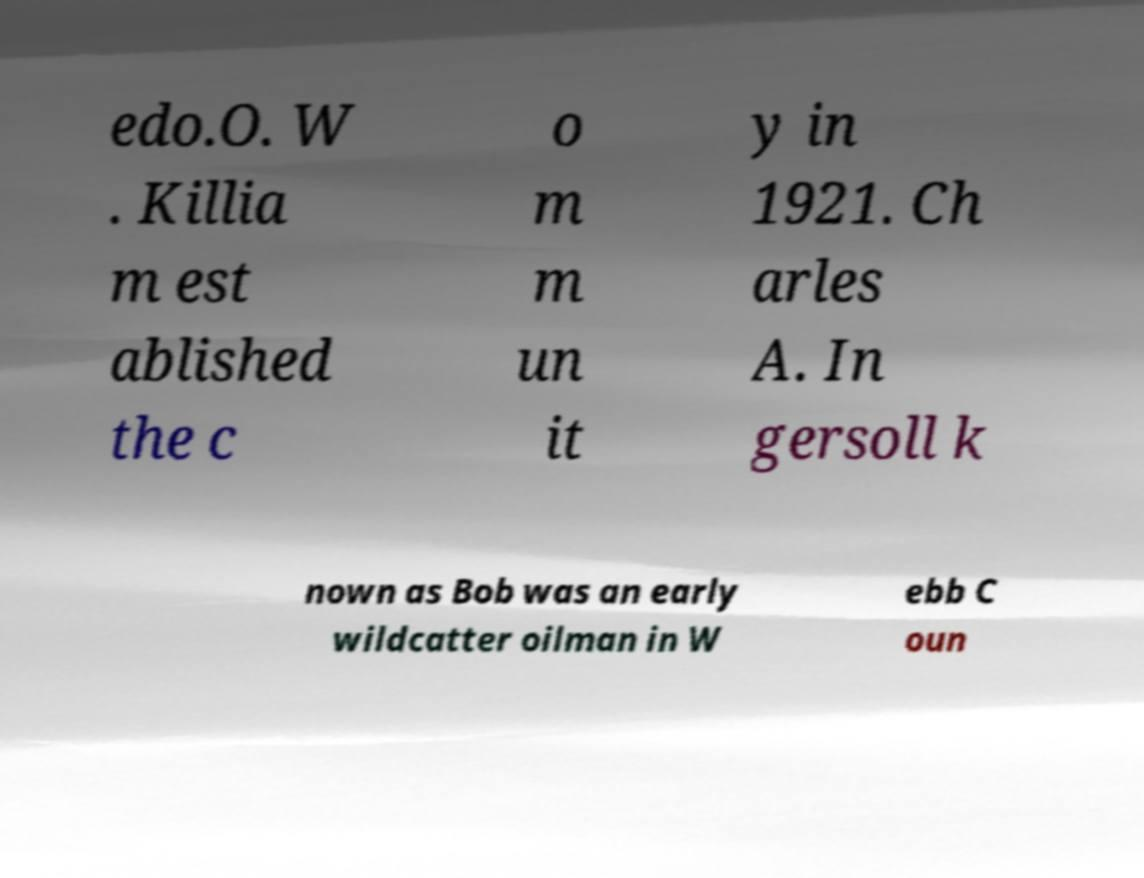For documentation purposes, I need the text within this image transcribed. Could you provide that? edo.O. W . Killia m est ablished the c o m m un it y in 1921. Ch arles A. In gersoll k nown as Bob was an early wildcatter oilman in W ebb C oun 